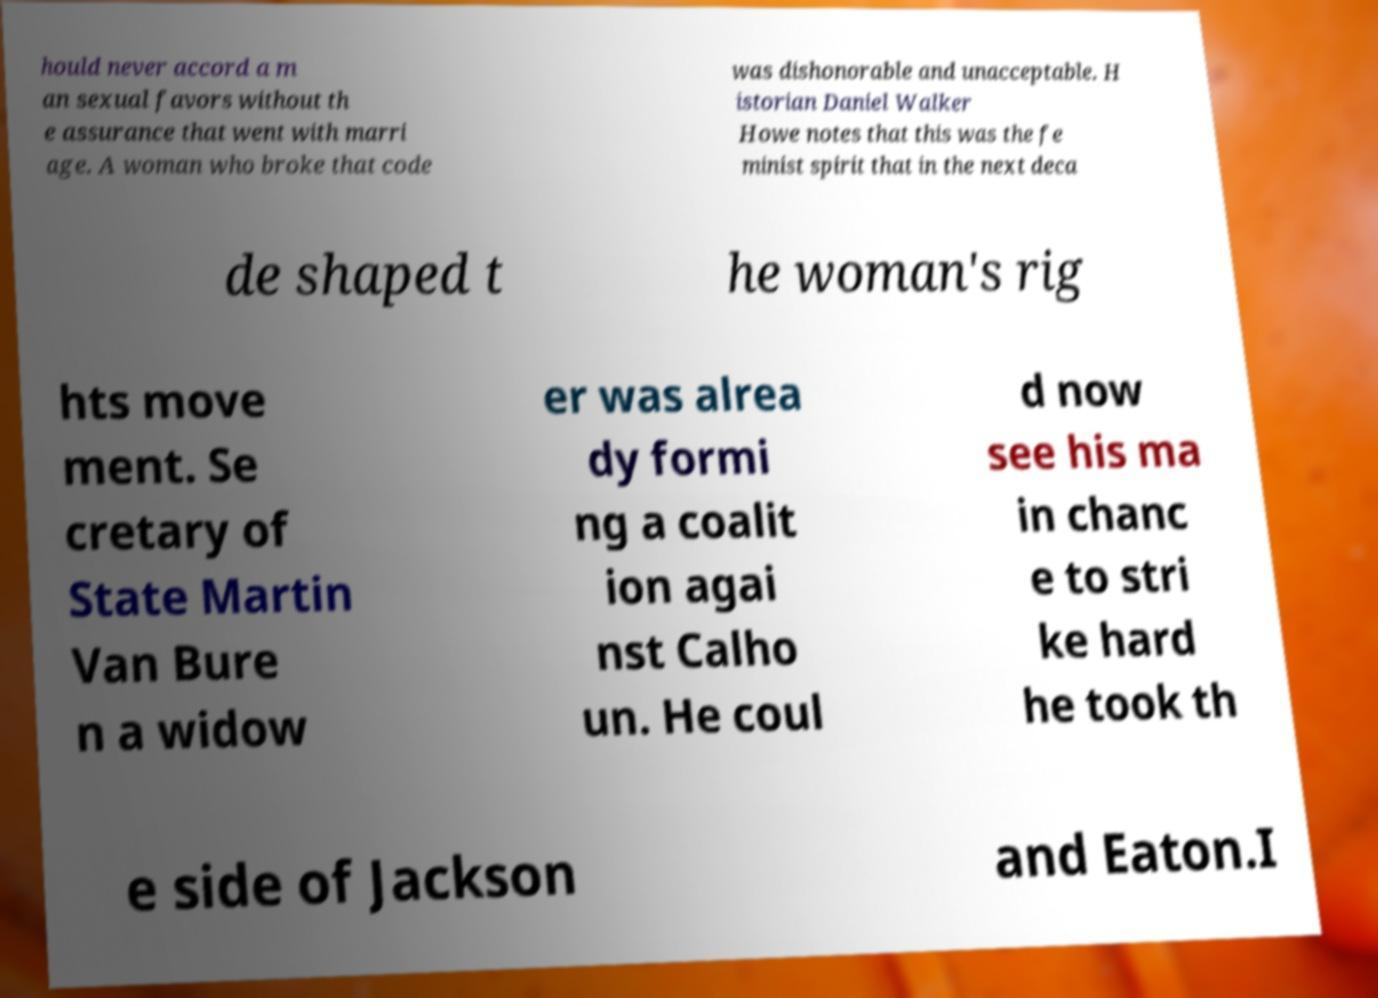There's text embedded in this image that I need extracted. Can you transcribe it verbatim? hould never accord a m an sexual favors without th e assurance that went with marri age. A woman who broke that code was dishonorable and unacceptable. H istorian Daniel Walker Howe notes that this was the fe minist spirit that in the next deca de shaped t he woman's rig hts move ment. Se cretary of State Martin Van Bure n a widow er was alrea dy formi ng a coalit ion agai nst Calho un. He coul d now see his ma in chanc e to stri ke hard he took th e side of Jackson and Eaton.I 